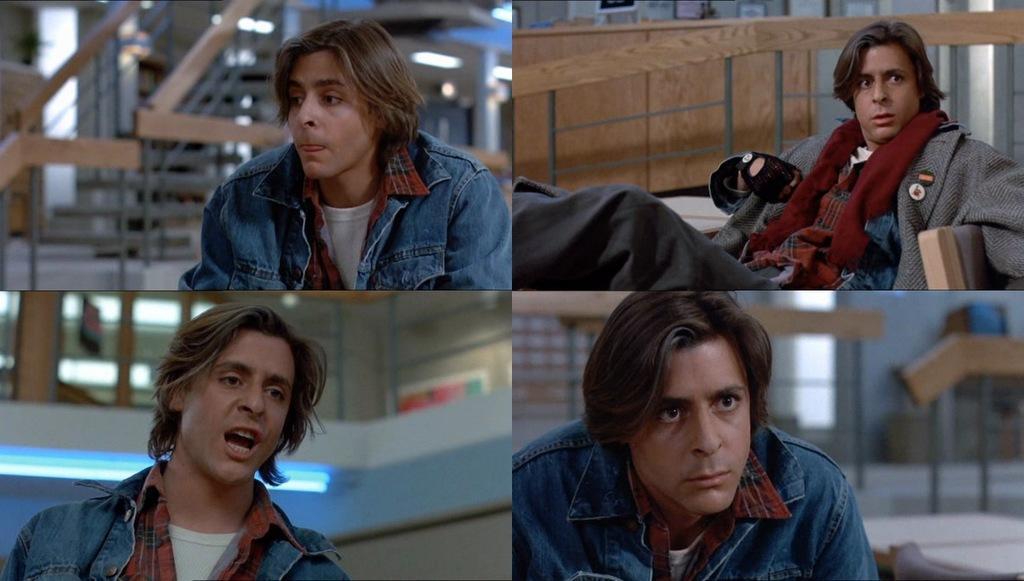Please provide a concise description of this image. This is a collage picture. I can see a man sitting, and in the background there are stairs, lights and some other objects. 